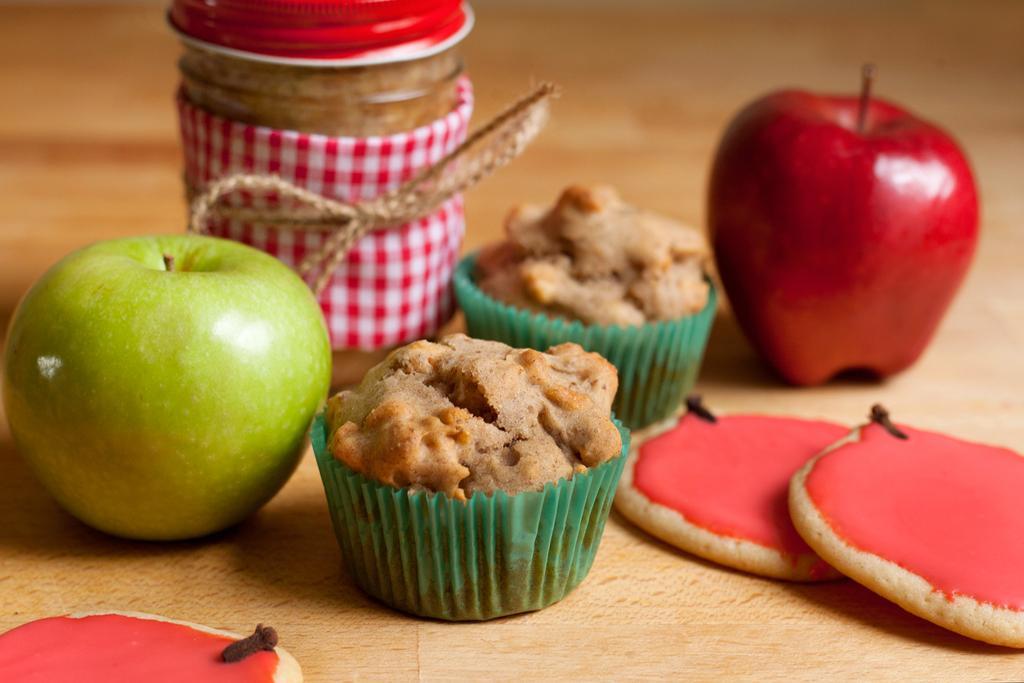Can you describe this image briefly? In this image there are two cupcakes one beside the other. On the right side there is an apple. On the left side there is a jar which is tied with the rope. At the bottom there is sweet. On the left side there is a green apple. 